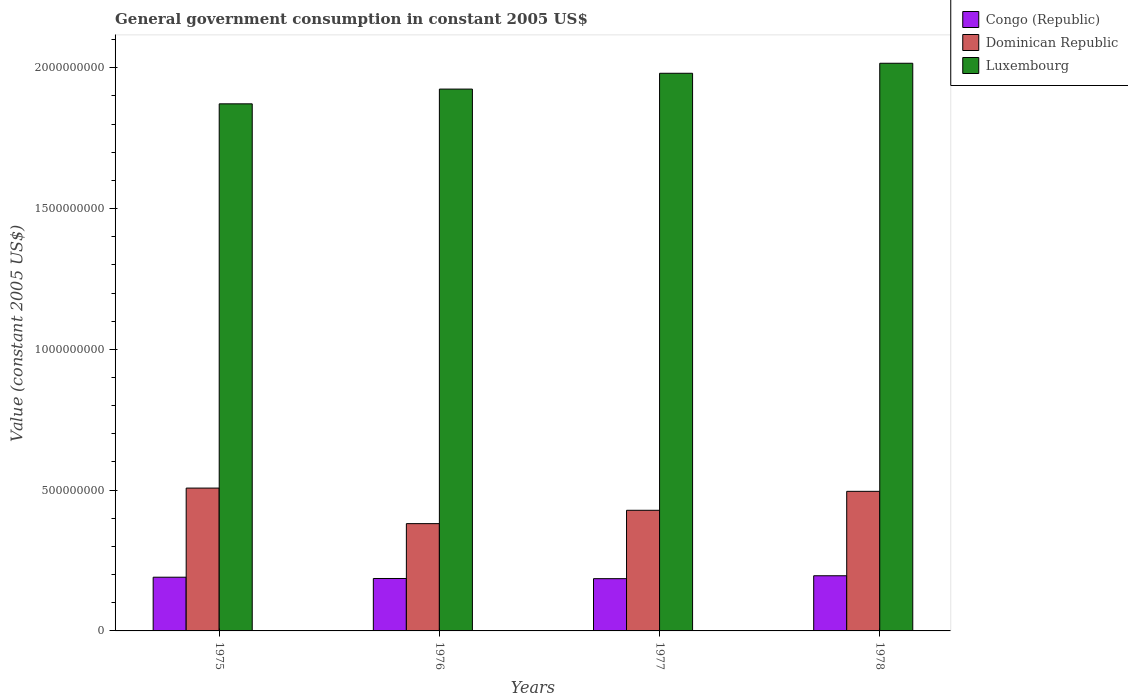How many different coloured bars are there?
Give a very brief answer. 3. How many groups of bars are there?
Offer a very short reply. 4. Are the number of bars per tick equal to the number of legend labels?
Your answer should be very brief. Yes. How many bars are there on the 3rd tick from the left?
Your response must be concise. 3. How many bars are there on the 4th tick from the right?
Keep it short and to the point. 3. What is the label of the 1st group of bars from the left?
Your answer should be very brief. 1975. In how many cases, is the number of bars for a given year not equal to the number of legend labels?
Your response must be concise. 0. What is the government conusmption in Congo (Republic) in 1977?
Provide a short and direct response. 1.86e+08. Across all years, what is the maximum government conusmption in Luxembourg?
Ensure brevity in your answer.  2.02e+09. Across all years, what is the minimum government conusmption in Congo (Republic)?
Your response must be concise. 1.86e+08. In which year was the government conusmption in Congo (Republic) maximum?
Provide a short and direct response. 1978. In which year was the government conusmption in Luxembourg minimum?
Offer a very short reply. 1975. What is the total government conusmption in Dominican Republic in the graph?
Your response must be concise. 1.81e+09. What is the difference between the government conusmption in Dominican Republic in 1975 and that in 1976?
Keep it short and to the point. 1.26e+08. What is the difference between the government conusmption in Luxembourg in 1976 and the government conusmption in Dominican Republic in 1978?
Ensure brevity in your answer.  1.43e+09. What is the average government conusmption in Dominican Republic per year?
Keep it short and to the point. 4.53e+08. In the year 1977, what is the difference between the government conusmption in Luxembourg and government conusmption in Congo (Republic)?
Give a very brief answer. 1.79e+09. What is the ratio of the government conusmption in Dominican Republic in 1975 to that in 1978?
Offer a very short reply. 1.02. Is the difference between the government conusmption in Luxembourg in 1977 and 1978 greater than the difference between the government conusmption in Congo (Republic) in 1977 and 1978?
Ensure brevity in your answer.  No. What is the difference between the highest and the second highest government conusmption in Congo (Republic)?
Keep it short and to the point. 5.15e+06. What is the difference between the highest and the lowest government conusmption in Congo (Republic)?
Offer a very short reply. 1.03e+07. What does the 3rd bar from the left in 1978 represents?
Offer a very short reply. Luxembourg. What does the 2nd bar from the right in 1975 represents?
Provide a succinct answer. Dominican Republic. Is it the case that in every year, the sum of the government conusmption in Luxembourg and government conusmption in Dominican Republic is greater than the government conusmption in Congo (Republic)?
Make the answer very short. Yes. How many years are there in the graph?
Ensure brevity in your answer.  4. What is the difference between two consecutive major ticks on the Y-axis?
Make the answer very short. 5.00e+08. Are the values on the major ticks of Y-axis written in scientific E-notation?
Give a very brief answer. No. Does the graph contain any zero values?
Offer a terse response. No. Does the graph contain grids?
Your answer should be compact. No. Where does the legend appear in the graph?
Your answer should be very brief. Top right. How many legend labels are there?
Your response must be concise. 3. What is the title of the graph?
Ensure brevity in your answer.  General government consumption in constant 2005 US$. Does "Sao Tome and Principe" appear as one of the legend labels in the graph?
Provide a succinct answer. No. What is the label or title of the X-axis?
Provide a succinct answer. Years. What is the label or title of the Y-axis?
Your answer should be compact. Value (constant 2005 US$). What is the Value (constant 2005 US$) of Congo (Republic) in 1975?
Make the answer very short. 1.91e+08. What is the Value (constant 2005 US$) in Dominican Republic in 1975?
Offer a very short reply. 5.07e+08. What is the Value (constant 2005 US$) in Luxembourg in 1975?
Offer a terse response. 1.87e+09. What is the Value (constant 2005 US$) of Congo (Republic) in 1976?
Offer a terse response. 1.86e+08. What is the Value (constant 2005 US$) of Dominican Republic in 1976?
Make the answer very short. 3.81e+08. What is the Value (constant 2005 US$) of Luxembourg in 1976?
Make the answer very short. 1.92e+09. What is the Value (constant 2005 US$) in Congo (Republic) in 1977?
Provide a succinct answer. 1.86e+08. What is the Value (constant 2005 US$) of Dominican Republic in 1977?
Give a very brief answer. 4.28e+08. What is the Value (constant 2005 US$) in Luxembourg in 1977?
Your answer should be very brief. 1.98e+09. What is the Value (constant 2005 US$) in Congo (Republic) in 1978?
Your response must be concise. 1.96e+08. What is the Value (constant 2005 US$) in Dominican Republic in 1978?
Offer a very short reply. 4.96e+08. What is the Value (constant 2005 US$) of Luxembourg in 1978?
Your answer should be very brief. 2.02e+09. Across all years, what is the maximum Value (constant 2005 US$) of Congo (Republic)?
Provide a short and direct response. 1.96e+08. Across all years, what is the maximum Value (constant 2005 US$) in Dominican Republic?
Your response must be concise. 5.07e+08. Across all years, what is the maximum Value (constant 2005 US$) in Luxembourg?
Offer a very short reply. 2.02e+09. Across all years, what is the minimum Value (constant 2005 US$) in Congo (Republic)?
Provide a succinct answer. 1.86e+08. Across all years, what is the minimum Value (constant 2005 US$) of Dominican Republic?
Ensure brevity in your answer.  3.81e+08. Across all years, what is the minimum Value (constant 2005 US$) of Luxembourg?
Provide a succinct answer. 1.87e+09. What is the total Value (constant 2005 US$) of Congo (Republic) in the graph?
Provide a succinct answer. 7.58e+08. What is the total Value (constant 2005 US$) of Dominican Republic in the graph?
Keep it short and to the point. 1.81e+09. What is the total Value (constant 2005 US$) in Luxembourg in the graph?
Your response must be concise. 7.79e+09. What is the difference between the Value (constant 2005 US$) of Congo (Republic) in 1975 and that in 1976?
Provide a short and direct response. 4.51e+06. What is the difference between the Value (constant 2005 US$) of Dominican Republic in 1975 and that in 1976?
Ensure brevity in your answer.  1.26e+08. What is the difference between the Value (constant 2005 US$) of Luxembourg in 1975 and that in 1976?
Provide a short and direct response. -5.24e+07. What is the difference between the Value (constant 2005 US$) of Congo (Republic) in 1975 and that in 1977?
Your answer should be compact. 5.15e+06. What is the difference between the Value (constant 2005 US$) in Dominican Republic in 1975 and that in 1977?
Your answer should be very brief. 7.88e+07. What is the difference between the Value (constant 2005 US$) in Luxembourg in 1975 and that in 1977?
Provide a succinct answer. -1.09e+08. What is the difference between the Value (constant 2005 US$) in Congo (Republic) in 1975 and that in 1978?
Keep it short and to the point. -5.15e+06. What is the difference between the Value (constant 2005 US$) in Dominican Republic in 1975 and that in 1978?
Your answer should be compact. 1.16e+07. What is the difference between the Value (constant 2005 US$) of Luxembourg in 1975 and that in 1978?
Offer a terse response. -1.44e+08. What is the difference between the Value (constant 2005 US$) in Congo (Republic) in 1976 and that in 1977?
Ensure brevity in your answer.  6.44e+05. What is the difference between the Value (constant 2005 US$) of Dominican Republic in 1976 and that in 1977?
Provide a short and direct response. -4.74e+07. What is the difference between the Value (constant 2005 US$) of Luxembourg in 1976 and that in 1977?
Provide a short and direct response. -5.62e+07. What is the difference between the Value (constant 2005 US$) in Congo (Republic) in 1976 and that in 1978?
Make the answer very short. -9.67e+06. What is the difference between the Value (constant 2005 US$) of Dominican Republic in 1976 and that in 1978?
Your answer should be very brief. -1.15e+08. What is the difference between the Value (constant 2005 US$) in Luxembourg in 1976 and that in 1978?
Ensure brevity in your answer.  -9.17e+07. What is the difference between the Value (constant 2005 US$) in Congo (Republic) in 1977 and that in 1978?
Make the answer very short. -1.03e+07. What is the difference between the Value (constant 2005 US$) of Dominican Republic in 1977 and that in 1978?
Make the answer very short. -6.73e+07. What is the difference between the Value (constant 2005 US$) of Luxembourg in 1977 and that in 1978?
Offer a very short reply. -3.56e+07. What is the difference between the Value (constant 2005 US$) of Congo (Republic) in 1975 and the Value (constant 2005 US$) of Dominican Republic in 1976?
Your answer should be compact. -1.90e+08. What is the difference between the Value (constant 2005 US$) of Congo (Republic) in 1975 and the Value (constant 2005 US$) of Luxembourg in 1976?
Offer a terse response. -1.73e+09. What is the difference between the Value (constant 2005 US$) in Dominican Republic in 1975 and the Value (constant 2005 US$) in Luxembourg in 1976?
Provide a succinct answer. -1.42e+09. What is the difference between the Value (constant 2005 US$) of Congo (Republic) in 1975 and the Value (constant 2005 US$) of Dominican Republic in 1977?
Ensure brevity in your answer.  -2.38e+08. What is the difference between the Value (constant 2005 US$) of Congo (Republic) in 1975 and the Value (constant 2005 US$) of Luxembourg in 1977?
Make the answer very short. -1.79e+09. What is the difference between the Value (constant 2005 US$) of Dominican Republic in 1975 and the Value (constant 2005 US$) of Luxembourg in 1977?
Make the answer very short. -1.47e+09. What is the difference between the Value (constant 2005 US$) of Congo (Republic) in 1975 and the Value (constant 2005 US$) of Dominican Republic in 1978?
Your answer should be very brief. -3.05e+08. What is the difference between the Value (constant 2005 US$) in Congo (Republic) in 1975 and the Value (constant 2005 US$) in Luxembourg in 1978?
Keep it short and to the point. -1.83e+09. What is the difference between the Value (constant 2005 US$) of Dominican Republic in 1975 and the Value (constant 2005 US$) of Luxembourg in 1978?
Ensure brevity in your answer.  -1.51e+09. What is the difference between the Value (constant 2005 US$) of Congo (Republic) in 1976 and the Value (constant 2005 US$) of Dominican Republic in 1977?
Offer a very short reply. -2.42e+08. What is the difference between the Value (constant 2005 US$) of Congo (Republic) in 1976 and the Value (constant 2005 US$) of Luxembourg in 1977?
Offer a very short reply. -1.79e+09. What is the difference between the Value (constant 2005 US$) in Dominican Republic in 1976 and the Value (constant 2005 US$) in Luxembourg in 1977?
Offer a terse response. -1.60e+09. What is the difference between the Value (constant 2005 US$) of Congo (Republic) in 1976 and the Value (constant 2005 US$) of Dominican Republic in 1978?
Make the answer very short. -3.09e+08. What is the difference between the Value (constant 2005 US$) of Congo (Republic) in 1976 and the Value (constant 2005 US$) of Luxembourg in 1978?
Provide a short and direct response. -1.83e+09. What is the difference between the Value (constant 2005 US$) of Dominican Republic in 1976 and the Value (constant 2005 US$) of Luxembourg in 1978?
Keep it short and to the point. -1.63e+09. What is the difference between the Value (constant 2005 US$) of Congo (Republic) in 1977 and the Value (constant 2005 US$) of Dominican Republic in 1978?
Provide a short and direct response. -3.10e+08. What is the difference between the Value (constant 2005 US$) in Congo (Republic) in 1977 and the Value (constant 2005 US$) in Luxembourg in 1978?
Provide a short and direct response. -1.83e+09. What is the difference between the Value (constant 2005 US$) of Dominican Republic in 1977 and the Value (constant 2005 US$) of Luxembourg in 1978?
Keep it short and to the point. -1.59e+09. What is the average Value (constant 2005 US$) of Congo (Republic) per year?
Ensure brevity in your answer.  1.90e+08. What is the average Value (constant 2005 US$) of Dominican Republic per year?
Offer a terse response. 4.53e+08. What is the average Value (constant 2005 US$) in Luxembourg per year?
Give a very brief answer. 1.95e+09. In the year 1975, what is the difference between the Value (constant 2005 US$) of Congo (Republic) and Value (constant 2005 US$) of Dominican Republic?
Give a very brief answer. -3.17e+08. In the year 1975, what is the difference between the Value (constant 2005 US$) of Congo (Republic) and Value (constant 2005 US$) of Luxembourg?
Keep it short and to the point. -1.68e+09. In the year 1975, what is the difference between the Value (constant 2005 US$) of Dominican Republic and Value (constant 2005 US$) of Luxembourg?
Ensure brevity in your answer.  -1.36e+09. In the year 1976, what is the difference between the Value (constant 2005 US$) of Congo (Republic) and Value (constant 2005 US$) of Dominican Republic?
Your response must be concise. -1.95e+08. In the year 1976, what is the difference between the Value (constant 2005 US$) of Congo (Republic) and Value (constant 2005 US$) of Luxembourg?
Keep it short and to the point. -1.74e+09. In the year 1976, what is the difference between the Value (constant 2005 US$) of Dominican Republic and Value (constant 2005 US$) of Luxembourg?
Make the answer very short. -1.54e+09. In the year 1977, what is the difference between the Value (constant 2005 US$) in Congo (Republic) and Value (constant 2005 US$) in Dominican Republic?
Ensure brevity in your answer.  -2.43e+08. In the year 1977, what is the difference between the Value (constant 2005 US$) in Congo (Republic) and Value (constant 2005 US$) in Luxembourg?
Offer a terse response. -1.79e+09. In the year 1977, what is the difference between the Value (constant 2005 US$) of Dominican Republic and Value (constant 2005 US$) of Luxembourg?
Offer a very short reply. -1.55e+09. In the year 1978, what is the difference between the Value (constant 2005 US$) in Congo (Republic) and Value (constant 2005 US$) in Dominican Republic?
Your answer should be compact. -3.00e+08. In the year 1978, what is the difference between the Value (constant 2005 US$) of Congo (Republic) and Value (constant 2005 US$) of Luxembourg?
Offer a very short reply. -1.82e+09. In the year 1978, what is the difference between the Value (constant 2005 US$) of Dominican Republic and Value (constant 2005 US$) of Luxembourg?
Make the answer very short. -1.52e+09. What is the ratio of the Value (constant 2005 US$) of Congo (Republic) in 1975 to that in 1976?
Your answer should be compact. 1.02. What is the ratio of the Value (constant 2005 US$) of Dominican Republic in 1975 to that in 1976?
Your response must be concise. 1.33. What is the ratio of the Value (constant 2005 US$) in Luxembourg in 1975 to that in 1976?
Your response must be concise. 0.97. What is the ratio of the Value (constant 2005 US$) in Congo (Republic) in 1975 to that in 1977?
Offer a very short reply. 1.03. What is the ratio of the Value (constant 2005 US$) of Dominican Republic in 1975 to that in 1977?
Provide a succinct answer. 1.18. What is the ratio of the Value (constant 2005 US$) of Luxembourg in 1975 to that in 1977?
Offer a terse response. 0.95. What is the ratio of the Value (constant 2005 US$) of Congo (Republic) in 1975 to that in 1978?
Offer a terse response. 0.97. What is the ratio of the Value (constant 2005 US$) in Dominican Republic in 1975 to that in 1978?
Provide a short and direct response. 1.02. What is the ratio of the Value (constant 2005 US$) of Luxembourg in 1975 to that in 1978?
Make the answer very short. 0.93. What is the ratio of the Value (constant 2005 US$) of Dominican Republic in 1976 to that in 1977?
Offer a terse response. 0.89. What is the ratio of the Value (constant 2005 US$) of Luxembourg in 1976 to that in 1977?
Keep it short and to the point. 0.97. What is the ratio of the Value (constant 2005 US$) in Congo (Republic) in 1976 to that in 1978?
Your answer should be compact. 0.95. What is the ratio of the Value (constant 2005 US$) of Dominican Republic in 1976 to that in 1978?
Offer a terse response. 0.77. What is the ratio of the Value (constant 2005 US$) in Luxembourg in 1976 to that in 1978?
Offer a very short reply. 0.95. What is the ratio of the Value (constant 2005 US$) of Congo (Republic) in 1977 to that in 1978?
Provide a short and direct response. 0.95. What is the ratio of the Value (constant 2005 US$) of Dominican Republic in 1977 to that in 1978?
Ensure brevity in your answer.  0.86. What is the ratio of the Value (constant 2005 US$) of Luxembourg in 1977 to that in 1978?
Provide a short and direct response. 0.98. What is the difference between the highest and the second highest Value (constant 2005 US$) in Congo (Republic)?
Offer a terse response. 5.15e+06. What is the difference between the highest and the second highest Value (constant 2005 US$) of Dominican Republic?
Keep it short and to the point. 1.16e+07. What is the difference between the highest and the second highest Value (constant 2005 US$) in Luxembourg?
Make the answer very short. 3.56e+07. What is the difference between the highest and the lowest Value (constant 2005 US$) of Congo (Republic)?
Your response must be concise. 1.03e+07. What is the difference between the highest and the lowest Value (constant 2005 US$) of Dominican Republic?
Provide a succinct answer. 1.26e+08. What is the difference between the highest and the lowest Value (constant 2005 US$) in Luxembourg?
Your response must be concise. 1.44e+08. 